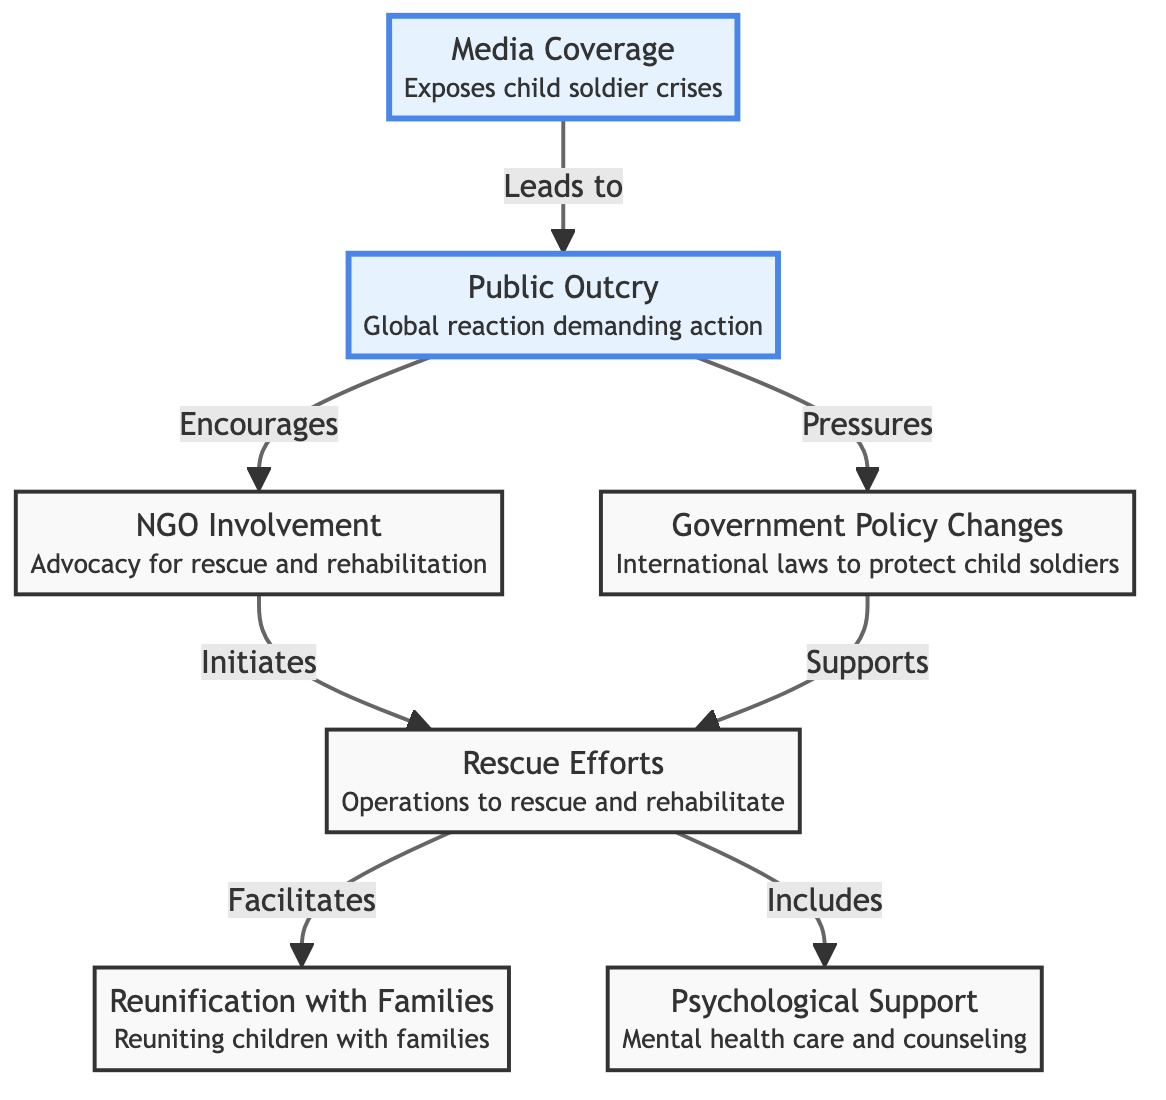What is the first node in the diagram? The first node shown in the diagram is "Media Coverage," which is positioned at the beginning of the flowchart.
Answer: Media Coverage How many total nodes are in the diagram? Counting all unique points in the flowchart, there are seven nodes represented: Media Coverage, Public Outcry, NGO Involvement, Government Policy Changes, Rescue Efforts, Reunification with Families, and Psychological Support.
Answer: 7 What does public outcry encourage? According to the diagram, public outcry encourages "NGO Involvement." This connection is indicated by the arrow pointing from public outcry to NGO involvement.
Answer: NGO Involvement Which node initiates rescue efforts? The diagram indicates that "NGO Involvement" initiates "Rescue Efforts," as shown by the arrow directed from the NGO Involvement node to the Rescue Efforts node.
Answer: NGO Involvement What type of support is included in rescue efforts? The diagram specifies that "Psychological Support" is included in the "Rescue Efforts," which is explicitly mentioned in the flowchart as one of the components of Rescue Efforts.
Answer: Psychological Support How does media coverage impact public outcry? Media coverage leads to public outcry, as illustrated by the direct arrow from the Media Coverage node to the Public Outcry node. This shows a causal relationship where media attention raises awareness, resulting in public concern.
Answer: Leads to What actions does public outcry pressure the government to change? Public outcry pressures "Government Policy Changes," as indicated by the arrow pointing from Public Outcry to Government Policy Changes, suggesting that increased public awareness causes a push for legal reforms.
Answer: Government Policy Changes How does government policy changes support rescue efforts? The diagram illustrates that government policy changes create a supportive framework for rescue efforts, as shown by an arrow from Government Policy Changes to Rescue Efforts, indicating that legal reforms and policies aid in facilitating operations to rescue children.
Answer: Supports What is the final outcome facilitated by rescue efforts? The final outcomes facilitated by rescue efforts are "Reunification with Families" and "Psychological Support," which are both achieved as part of the rescue effort process as depicted in the flowchart.
Answer: Reunification with Families, Psychological Support 